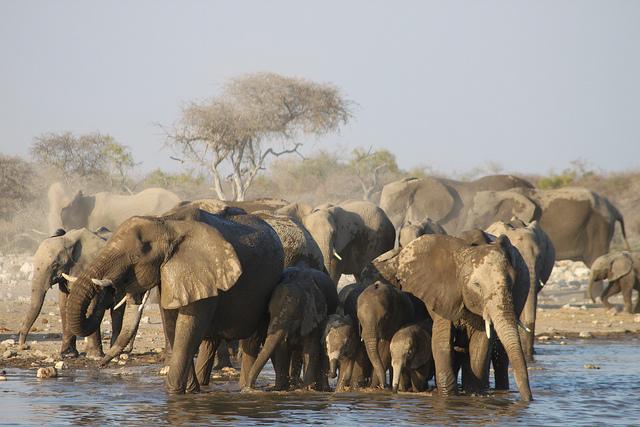What number of elephants are standing in the river?
Concise answer only. 7. How many elephant feet are wet?
Short answer required. 10. Are the elephants drinking?
Write a very short answer. Yes. What is behind the elephants?
Give a very brief answer. Trees. 